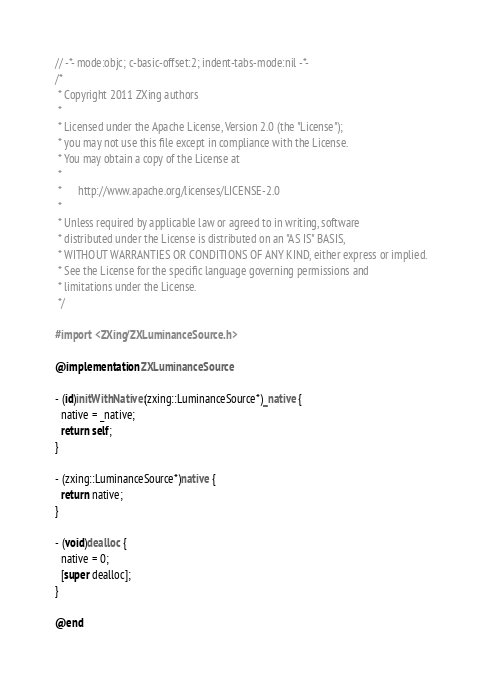<code> <loc_0><loc_0><loc_500><loc_500><_ObjectiveC_>// -*- mode:objc; c-basic-offset:2; indent-tabs-mode:nil -*-
/*
 * Copyright 2011 ZXing authors
 *
 * Licensed under the Apache License, Version 2.0 (the "License");
 * you may not use this file except in compliance with the License.
 * You may obtain a copy of the License at
 *
 *      http://www.apache.org/licenses/LICENSE-2.0
 *
 * Unless required by applicable law or agreed to in writing, software
 * distributed under the License is distributed on an "AS IS" BASIS,
 * WITHOUT WARRANTIES OR CONDITIONS OF ANY KIND, either express or implied.
 * See the License for the specific language governing permissions and
 * limitations under the License.
 */

#import <ZXing/ZXLuminanceSource.h>

@implementation ZXLuminanceSource

- (id)initWithNative:(zxing::LuminanceSource*)_native {
  native = _native;
  return self;
}

- (zxing::LuminanceSource*)native {
  return native;
}

- (void)dealloc {
  native = 0;
  [super dealloc];
}

@end
</code> 